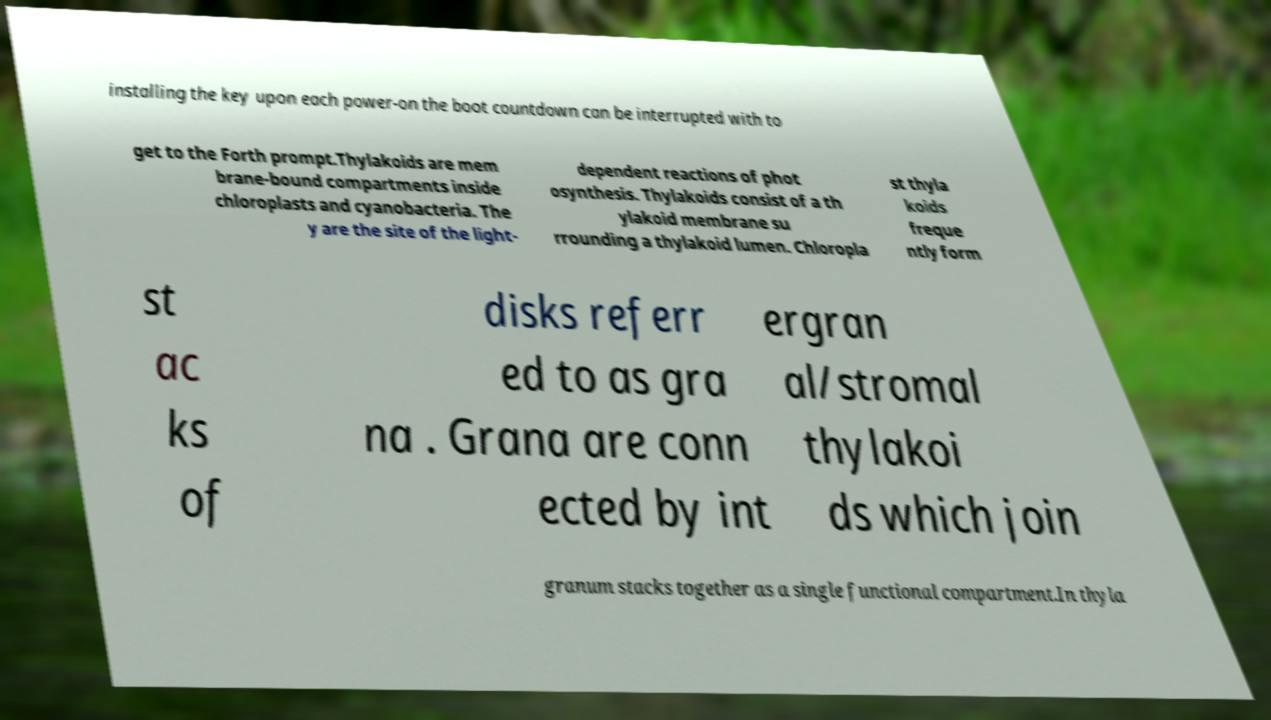Could you assist in decoding the text presented in this image and type it out clearly? installing the key upon each power-on the boot countdown can be interrupted with to get to the Forth prompt.Thylakoids are mem brane-bound compartments inside chloroplasts and cyanobacteria. The y are the site of the light- dependent reactions of phot osynthesis. Thylakoids consist of a th ylakoid membrane su rrounding a thylakoid lumen. Chloropla st thyla koids freque ntly form st ac ks of disks referr ed to as gra na . Grana are conn ected by int ergran al/stromal thylakoi ds which join granum stacks together as a single functional compartment.In thyla 